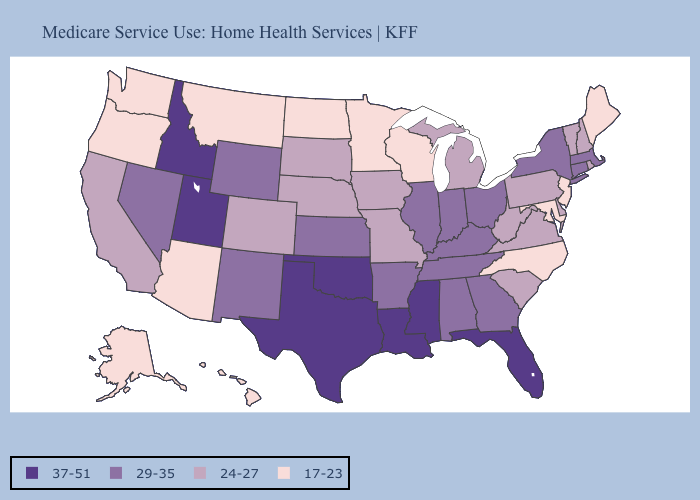Does Wyoming have the highest value in the USA?
Answer briefly. No. What is the value of Michigan?
Quick response, please. 24-27. Does West Virginia have a lower value than Louisiana?
Answer briefly. Yes. Does Pennsylvania have the highest value in the Northeast?
Answer briefly. No. What is the value of South Dakota?
Quick response, please. 24-27. Which states have the highest value in the USA?
Write a very short answer. Florida, Idaho, Louisiana, Mississippi, Oklahoma, Texas, Utah. Among the states that border South Carolina , does Georgia have the highest value?
Quick response, please. Yes. What is the lowest value in the MidWest?
Quick response, please. 17-23. Name the states that have a value in the range 17-23?
Short answer required. Alaska, Arizona, Hawaii, Maine, Maryland, Minnesota, Montana, New Jersey, North Carolina, North Dakota, Oregon, Washington, Wisconsin. What is the highest value in the South ?
Keep it brief. 37-51. What is the value of Arizona?
Short answer required. 17-23. What is the highest value in the USA?
Write a very short answer. 37-51. Among the states that border Kansas , which have the lowest value?
Be succinct. Colorado, Missouri, Nebraska. Which states hav the highest value in the Northeast?
Be succinct. Connecticut, Massachusetts, New York. What is the lowest value in the West?
Write a very short answer. 17-23. 